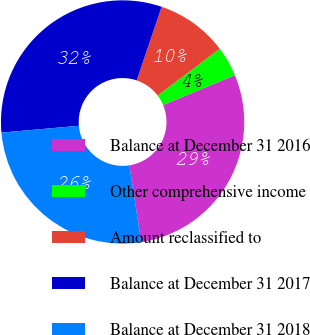Convert chart. <chart><loc_0><loc_0><loc_500><loc_500><pie_chart><fcel>Balance at December 31 2016<fcel>Other comprehensive income<fcel>Amount reclassified to<fcel>Balance at December 31 2017<fcel>Balance at December 31 2018<nl><fcel>28.83%<fcel>3.99%<fcel>9.53%<fcel>31.6%<fcel>26.06%<nl></chart> 